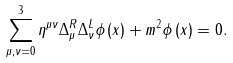<formula> <loc_0><loc_0><loc_500><loc_500>\sum ^ { 3 } _ { \mu , \nu = 0 } { \eta } ^ { \mu \nu } \Delta ^ { R } _ { \mu } \Delta ^ { L } _ { \nu } \phi \left ( x \right ) + m ^ { 2 } \phi \left ( x \right ) = 0 .</formula> 